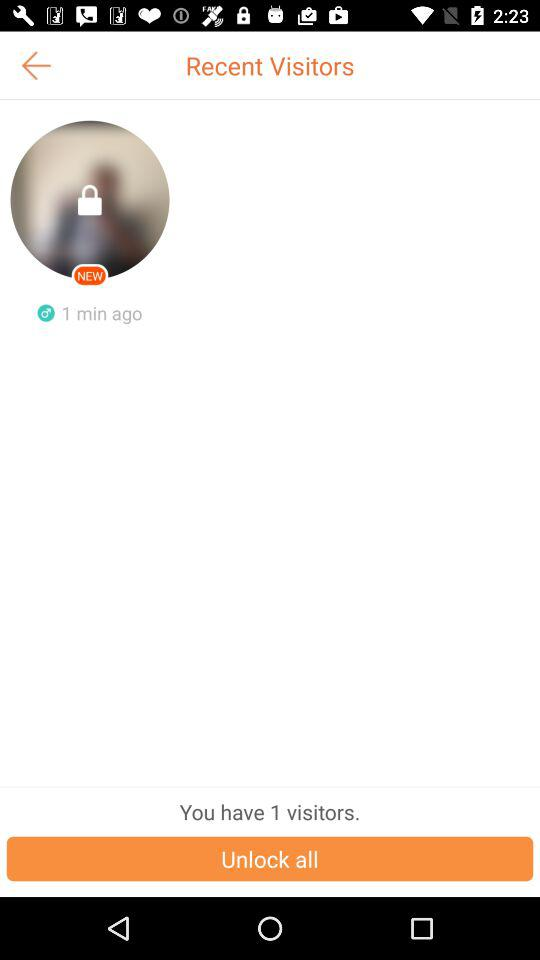How many visitors are there in total?
Answer the question using a single word or phrase. 1 